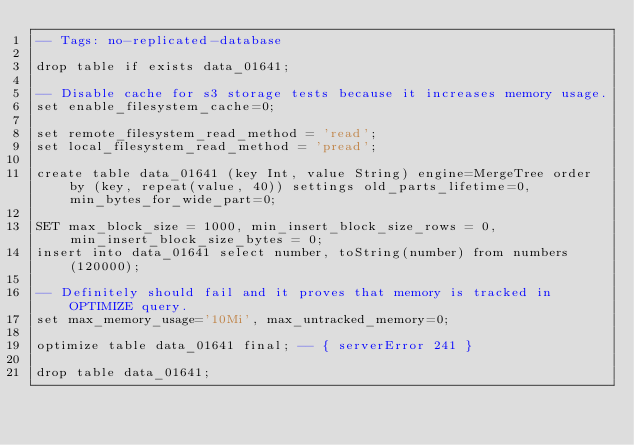<code> <loc_0><loc_0><loc_500><loc_500><_SQL_>-- Tags: no-replicated-database

drop table if exists data_01641;

-- Disable cache for s3 storage tests because it increases memory usage.
set enable_filesystem_cache=0;

set remote_filesystem_read_method = 'read';
set local_filesystem_read_method = 'pread';

create table data_01641 (key Int, value String) engine=MergeTree order by (key, repeat(value, 40)) settings old_parts_lifetime=0, min_bytes_for_wide_part=0;

SET max_block_size = 1000, min_insert_block_size_rows = 0, min_insert_block_size_bytes = 0;
insert into data_01641 select number, toString(number) from numbers(120000);

-- Definitely should fail and it proves that memory is tracked in OPTIMIZE query.
set max_memory_usage='10Mi', max_untracked_memory=0;

optimize table data_01641 final; -- { serverError 241 }

drop table data_01641;
</code> 